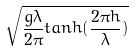Convert formula to latex. <formula><loc_0><loc_0><loc_500><loc_500>\sqrt { \frac { g \lambda } { 2 \pi } t a n h ( \frac { 2 \pi h } { \lambda } ) }</formula> 